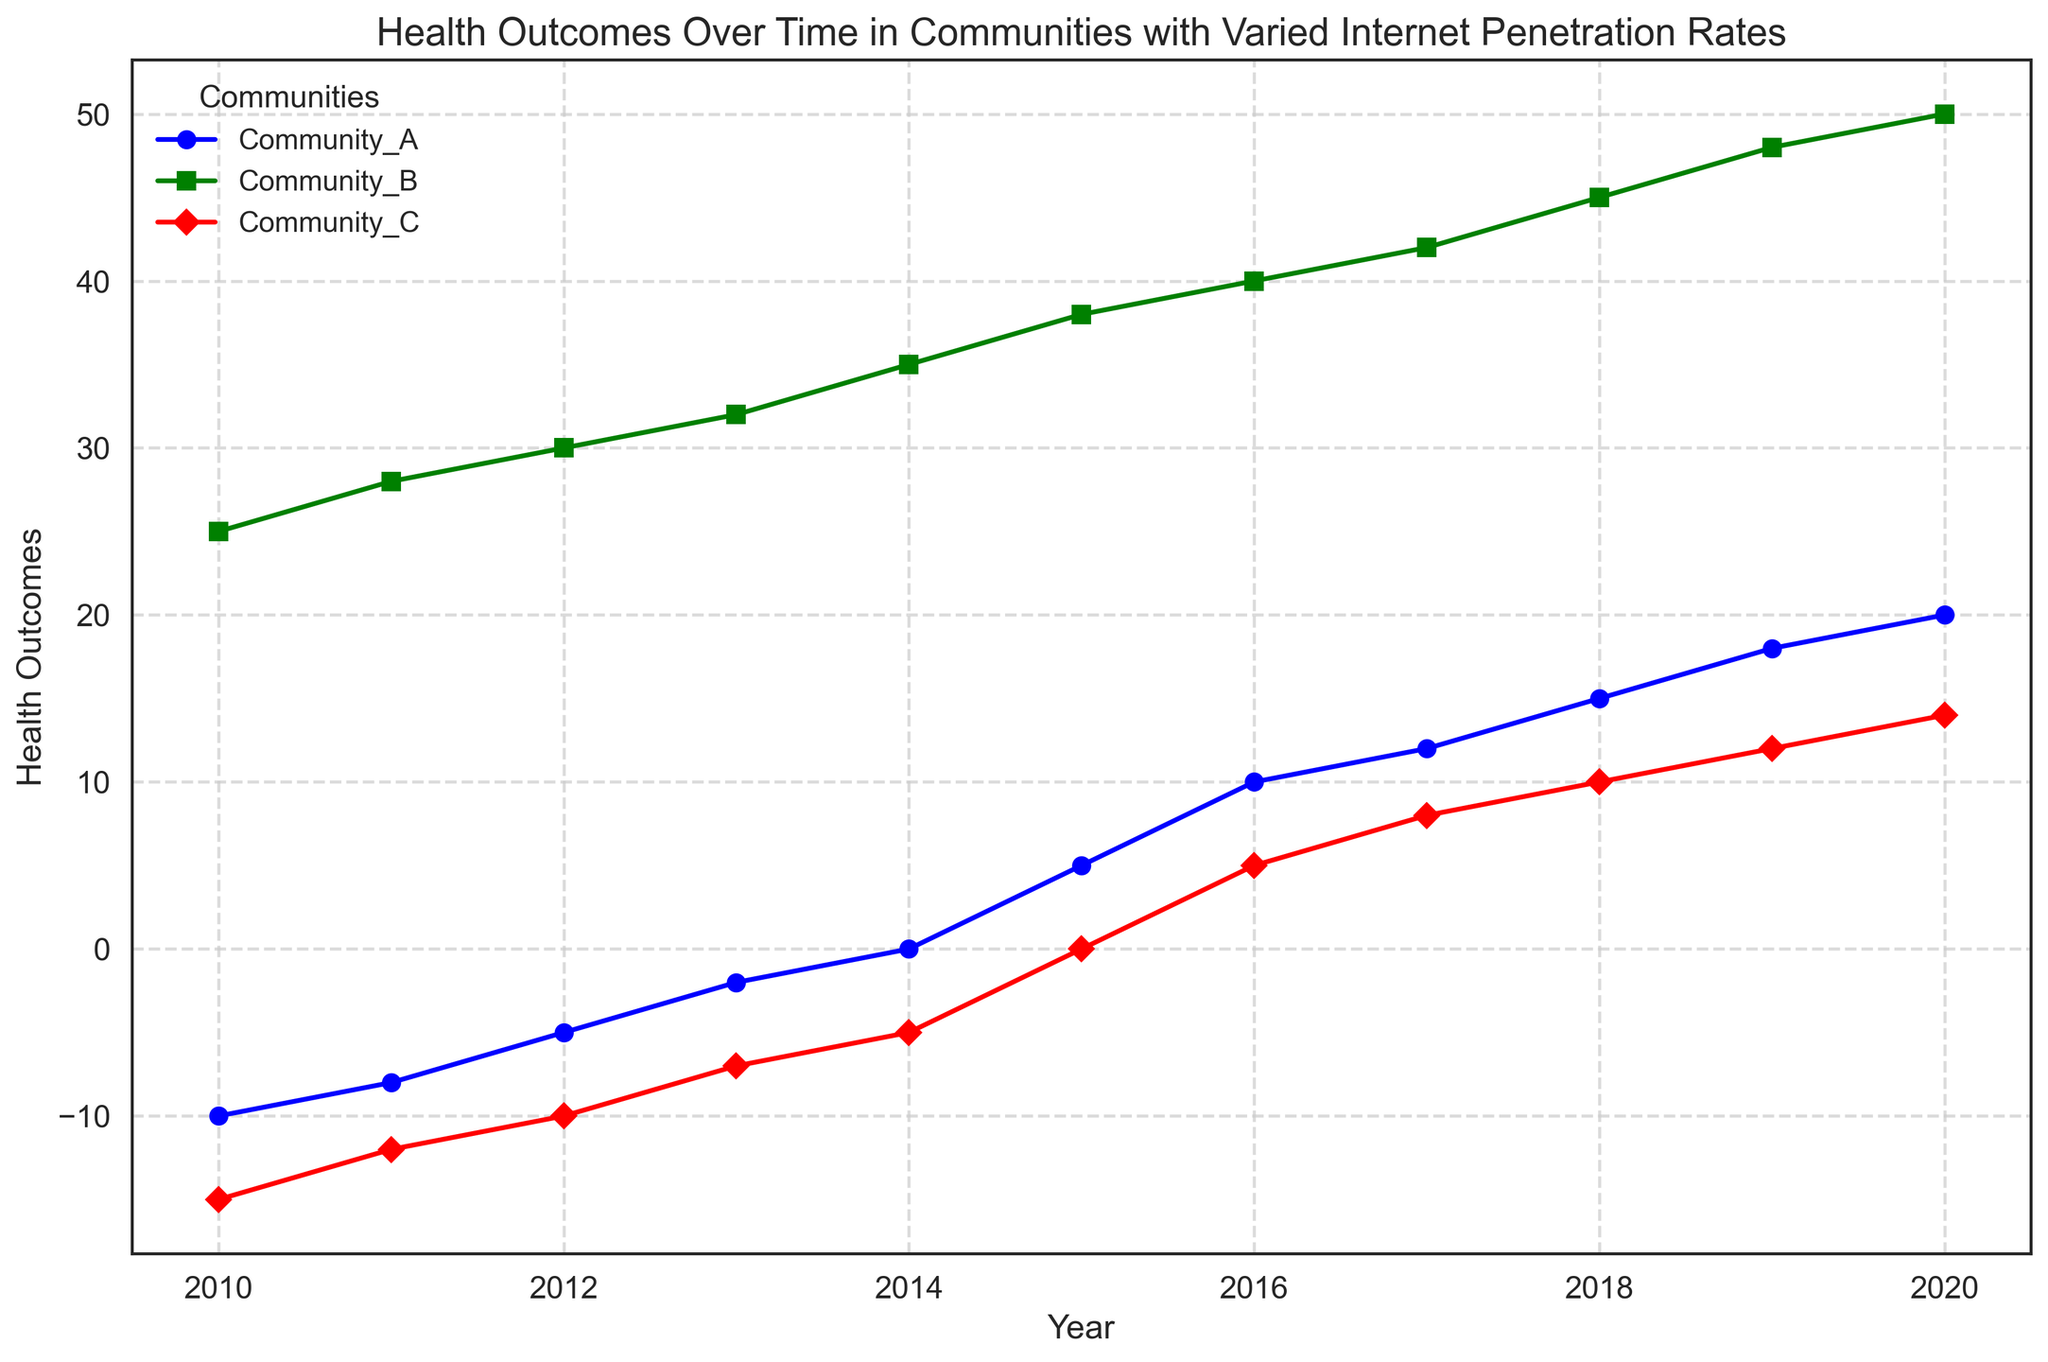What is the overall trend of health outcomes in Community_A from 2010 to 2020? Community_A's health outcomes start negatively at -10 in 2010 and gradually increase to positive values, reaching 20 in 2020. This shows a consistent improvement in health outcomes over the years.
Answer: Consistent improvement How do health outcomes in Community_B compare to those in Community_C in 2020? In 2020, the health outcomes for Community_B are 50, while for Community_C, they are 14. Community_B has significantly better health outcomes in comparison to Community_C for this year.
Answer: Community_B has better health outcomes What is the average health outcome in Community_C over the entire period? Summing up the health outcomes in Community_C from 2010 to 2020: (-15) + (-12) + (-10) + (-7) + (-5) + 0 + 5 + 8 + 10 + 12 + 14 = 0. Divide this sum by the number of years (11): 0 / 11 = 0.
Answer: 0 Which community showed the highest increase in health outcomes from 2010 to 2020? Community_A increased from -10 to 20 (30 points), Community_B increased from 25 to 50 (25 points), and Community_C increased from -15 to 14 (29 points). Community_A has the highest increase in health outcomes.
Answer: Community_A In which year did Community_A's health outcomes become non-negative for the first time? Community_A's health outcomes become non-negative (greater than or equal to 0) in 2014 for the first time, where the outcome is exactly 0.
Answer: 2014 Compare the health outcomes of Community_A and Community_B in 2015. In 2015, the health outcomes for Community_A are 5 and for Community_B, they are 38. Community_B has significantly higher health outcomes than Community_A in this year.
Answer: Community_B has higher outcomes What is the median health outcome for Community_B over the years provided? The health outcomes for Community_B are 25, 28, 30, 32, 35, 38, 40, 42, 45, 48, and 50. The median is the middle value in this ordered list, which is 38.
Answer: 38 How did the health outcomes of Community_C change between 2010 and 2015? In 2010, the health outcomes for Community_C are -15, and in 2015, they are 0. The change is 0 - (-15) = 15.
Answer: Increased by 15 What visual trend can be observed regarding the health outcomes of all three communities over the years? Health outcomes for all three communities generally show an upward trend over time, with Community_B consistently having the highest values followed by Community_A, and Community_C showing the least improvement but still moving towards positive health outcomes.
Answer: Upward trend for all 